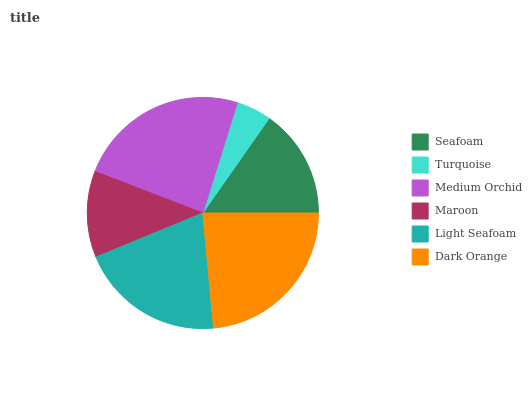Is Turquoise the minimum?
Answer yes or no. Yes. Is Medium Orchid the maximum?
Answer yes or no. Yes. Is Medium Orchid the minimum?
Answer yes or no. No. Is Turquoise the maximum?
Answer yes or no. No. Is Medium Orchid greater than Turquoise?
Answer yes or no. Yes. Is Turquoise less than Medium Orchid?
Answer yes or no. Yes. Is Turquoise greater than Medium Orchid?
Answer yes or no. No. Is Medium Orchid less than Turquoise?
Answer yes or no. No. Is Light Seafoam the high median?
Answer yes or no. Yes. Is Seafoam the low median?
Answer yes or no. Yes. Is Seafoam the high median?
Answer yes or no. No. Is Medium Orchid the low median?
Answer yes or no. No. 